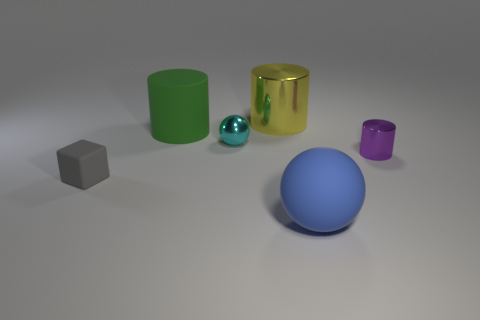Does the cyan sphere have the same size as the purple cylinder?
Your response must be concise. Yes. How many things are either small yellow spheres or purple metallic cylinders?
Offer a very short reply. 1. What shape is the shiny thing behind the large matte thing that is behind the metallic cylinder in front of the yellow metal cylinder?
Your answer should be very brief. Cylinder. Are the small object that is behind the small purple shiny thing and the large object behind the big green rubber cylinder made of the same material?
Give a very brief answer. Yes. There is another large thing that is the same shape as the cyan thing; what is its material?
Make the answer very short. Rubber. Does the big rubber thing right of the big green cylinder have the same shape as the tiny cyan thing in front of the green rubber cylinder?
Make the answer very short. Yes. Are there fewer blue spheres that are to the right of the small sphere than large things that are behind the tiny gray object?
Give a very brief answer. Yes. What number of other objects are there of the same shape as the green object?
Make the answer very short. 2. What shape is the blue object that is made of the same material as the gray thing?
Your response must be concise. Sphere. What is the color of the metallic thing that is both on the left side of the small shiny cylinder and in front of the big matte cylinder?
Offer a terse response. Cyan. 